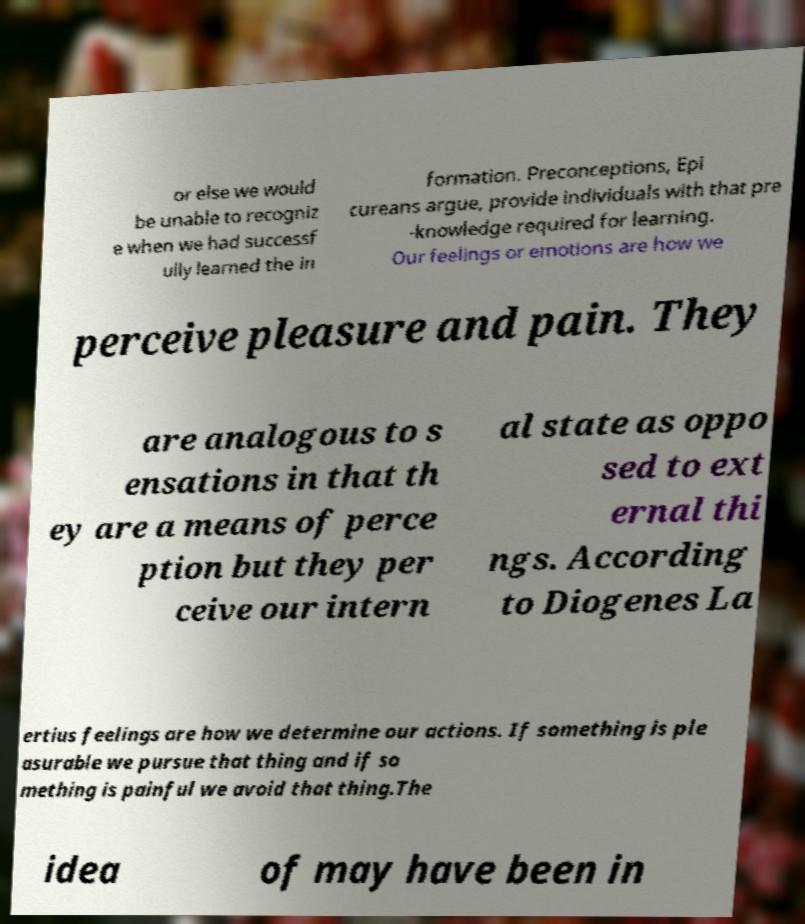What messages or text are displayed in this image? I need them in a readable, typed format. or else we would be unable to recogniz e when we had successf ully learned the in formation. Preconceptions, Epi cureans argue, provide individuals with that pre -knowledge required for learning. Our feelings or emotions are how we perceive pleasure and pain. They are analogous to s ensations in that th ey are a means of perce ption but they per ceive our intern al state as oppo sed to ext ernal thi ngs. According to Diogenes La ertius feelings are how we determine our actions. If something is ple asurable we pursue that thing and if so mething is painful we avoid that thing.The idea of may have been in 